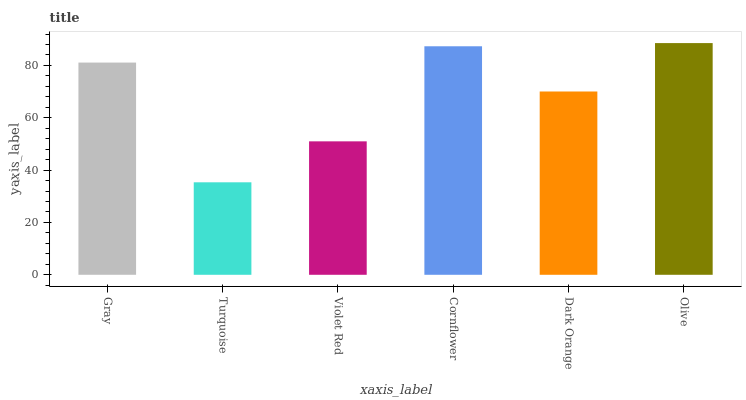Is Turquoise the minimum?
Answer yes or no. Yes. Is Olive the maximum?
Answer yes or no. Yes. Is Violet Red the minimum?
Answer yes or no. No. Is Violet Red the maximum?
Answer yes or no. No. Is Violet Red greater than Turquoise?
Answer yes or no. Yes. Is Turquoise less than Violet Red?
Answer yes or no. Yes. Is Turquoise greater than Violet Red?
Answer yes or no. No. Is Violet Red less than Turquoise?
Answer yes or no. No. Is Gray the high median?
Answer yes or no. Yes. Is Dark Orange the low median?
Answer yes or no. Yes. Is Turquoise the high median?
Answer yes or no. No. Is Turquoise the low median?
Answer yes or no. No. 